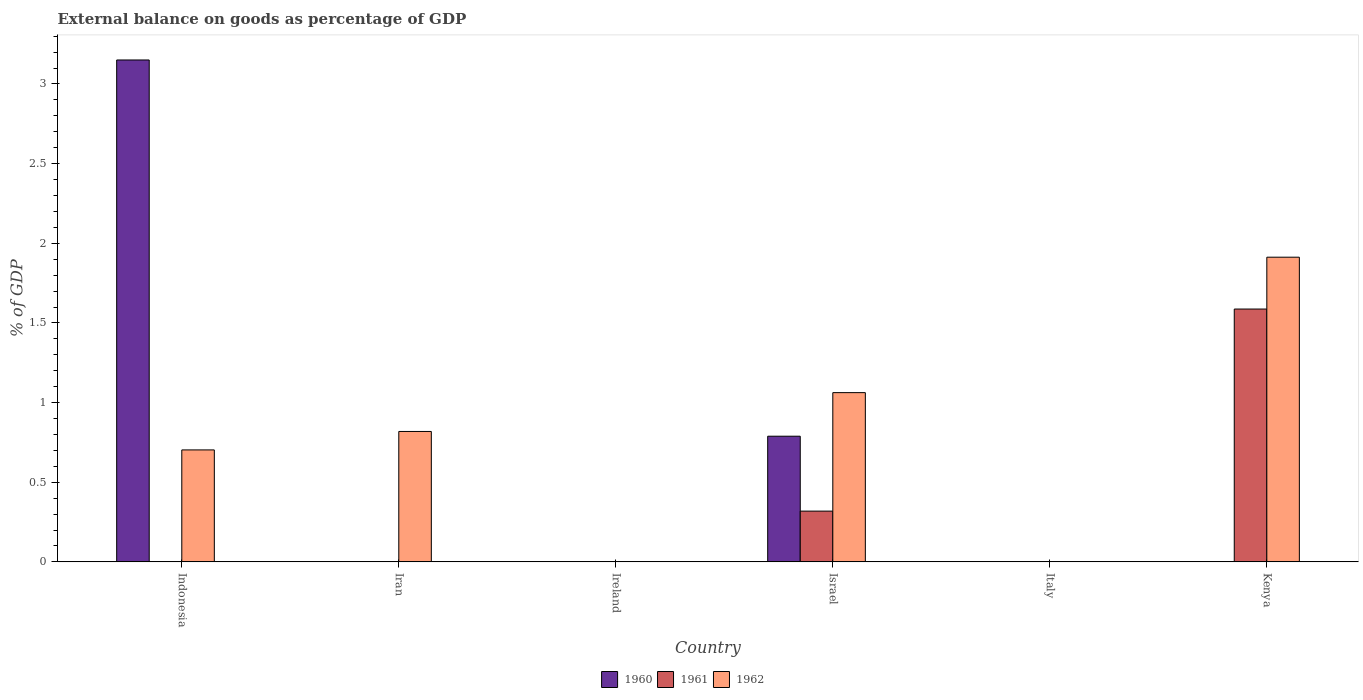How many different coloured bars are there?
Provide a short and direct response. 3. Are the number of bars per tick equal to the number of legend labels?
Provide a succinct answer. No. How many bars are there on the 3rd tick from the left?
Your answer should be very brief. 0. What is the label of the 3rd group of bars from the left?
Provide a succinct answer. Ireland. In how many cases, is the number of bars for a given country not equal to the number of legend labels?
Make the answer very short. 5. What is the external balance on goods as percentage of GDP in 1962 in Israel?
Provide a short and direct response. 1.06. Across all countries, what is the maximum external balance on goods as percentage of GDP in 1960?
Offer a terse response. 3.15. Across all countries, what is the minimum external balance on goods as percentage of GDP in 1961?
Your answer should be very brief. 0. In which country was the external balance on goods as percentage of GDP in 1961 maximum?
Offer a very short reply. Kenya. What is the total external balance on goods as percentage of GDP in 1961 in the graph?
Offer a terse response. 1.91. What is the difference between the external balance on goods as percentage of GDP in 1962 in Iran and that in Kenya?
Offer a terse response. -1.09. What is the difference between the external balance on goods as percentage of GDP in 1962 in Kenya and the external balance on goods as percentage of GDP in 1961 in Israel?
Provide a succinct answer. 1.59. What is the average external balance on goods as percentage of GDP in 1960 per country?
Give a very brief answer. 0.66. What is the difference between the external balance on goods as percentage of GDP of/in 1960 and external balance on goods as percentage of GDP of/in 1961 in Israel?
Offer a very short reply. 0.47. What is the ratio of the external balance on goods as percentage of GDP in 1962 in Iran to that in Israel?
Your answer should be very brief. 0.77. Is the external balance on goods as percentage of GDP in 1962 in Indonesia less than that in Iran?
Give a very brief answer. Yes. What is the difference between the highest and the second highest external balance on goods as percentage of GDP in 1962?
Provide a short and direct response. -1.09. What is the difference between the highest and the lowest external balance on goods as percentage of GDP in 1960?
Offer a very short reply. 3.15. Is the sum of the external balance on goods as percentage of GDP in 1962 in Israel and Kenya greater than the maximum external balance on goods as percentage of GDP in 1961 across all countries?
Provide a short and direct response. Yes. Is it the case that in every country, the sum of the external balance on goods as percentage of GDP in 1960 and external balance on goods as percentage of GDP in 1962 is greater than the external balance on goods as percentage of GDP in 1961?
Keep it short and to the point. No. How many bars are there?
Provide a succinct answer. 8. Are all the bars in the graph horizontal?
Give a very brief answer. No. How many countries are there in the graph?
Your response must be concise. 6. How many legend labels are there?
Offer a terse response. 3. What is the title of the graph?
Your response must be concise. External balance on goods as percentage of GDP. What is the label or title of the X-axis?
Offer a very short reply. Country. What is the label or title of the Y-axis?
Provide a short and direct response. % of GDP. What is the % of GDP of 1960 in Indonesia?
Provide a succinct answer. 3.15. What is the % of GDP in 1961 in Indonesia?
Your response must be concise. 0. What is the % of GDP of 1962 in Indonesia?
Ensure brevity in your answer.  0.7. What is the % of GDP of 1960 in Iran?
Offer a very short reply. 0. What is the % of GDP of 1961 in Iran?
Provide a succinct answer. 0. What is the % of GDP in 1962 in Iran?
Your answer should be very brief. 0.82. What is the % of GDP of 1961 in Ireland?
Your response must be concise. 0. What is the % of GDP in 1962 in Ireland?
Ensure brevity in your answer.  0. What is the % of GDP in 1960 in Israel?
Keep it short and to the point. 0.79. What is the % of GDP of 1961 in Israel?
Your answer should be compact. 0.32. What is the % of GDP of 1962 in Israel?
Keep it short and to the point. 1.06. What is the % of GDP of 1962 in Italy?
Provide a short and direct response. 0. What is the % of GDP of 1960 in Kenya?
Give a very brief answer. 0. What is the % of GDP of 1961 in Kenya?
Make the answer very short. 1.59. What is the % of GDP in 1962 in Kenya?
Offer a very short reply. 1.91. Across all countries, what is the maximum % of GDP in 1960?
Ensure brevity in your answer.  3.15. Across all countries, what is the maximum % of GDP of 1961?
Your answer should be compact. 1.59. Across all countries, what is the maximum % of GDP in 1962?
Your answer should be compact. 1.91. Across all countries, what is the minimum % of GDP of 1960?
Keep it short and to the point. 0. Across all countries, what is the minimum % of GDP of 1961?
Your answer should be compact. 0. Across all countries, what is the minimum % of GDP of 1962?
Your response must be concise. 0. What is the total % of GDP of 1960 in the graph?
Your response must be concise. 3.94. What is the total % of GDP of 1961 in the graph?
Offer a very short reply. 1.91. What is the total % of GDP in 1962 in the graph?
Keep it short and to the point. 4.5. What is the difference between the % of GDP in 1962 in Indonesia and that in Iran?
Make the answer very short. -0.12. What is the difference between the % of GDP in 1960 in Indonesia and that in Israel?
Provide a succinct answer. 2.36. What is the difference between the % of GDP of 1962 in Indonesia and that in Israel?
Keep it short and to the point. -0.36. What is the difference between the % of GDP in 1962 in Indonesia and that in Kenya?
Your answer should be very brief. -1.21. What is the difference between the % of GDP in 1962 in Iran and that in Israel?
Offer a very short reply. -0.24. What is the difference between the % of GDP in 1962 in Iran and that in Kenya?
Provide a short and direct response. -1.09. What is the difference between the % of GDP of 1961 in Israel and that in Kenya?
Keep it short and to the point. -1.27. What is the difference between the % of GDP in 1962 in Israel and that in Kenya?
Keep it short and to the point. -0.85. What is the difference between the % of GDP in 1960 in Indonesia and the % of GDP in 1962 in Iran?
Your response must be concise. 2.33. What is the difference between the % of GDP of 1960 in Indonesia and the % of GDP of 1961 in Israel?
Provide a succinct answer. 2.83. What is the difference between the % of GDP of 1960 in Indonesia and the % of GDP of 1962 in Israel?
Your answer should be very brief. 2.09. What is the difference between the % of GDP of 1960 in Indonesia and the % of GDP of 1961 in Kenya?
Your response must be concise. 1.56. What is the difference between the % of GDP in 1960 in Indonesia and the % of GDP in 1962 in Kenya?
Make the answer very short. 1.24. What is the difference between the % of GDP of 1960 in Israel and the % of GDP of 1961 in Kenya?
Provide a short and direct response. -0.8. What is the difference between the % of GDP in 1960 in Israel and the % of GDP in 1962 in Kenya?
Ensure brevity in your answer.  -1.12. What is the difference between the % of GDP of 1961 in Israel and the % of GDP of 1962 in Kenya?
Your answer should be compact. -1.59. What is the average % of GDP in 1960 per country?
Ensure brevity in your answer.  0.66. What is the average % of GDP of 1961 per country?
Ensure brevity in your answer.  0.32. What is the average % of GDP of 1962 per country?
Give a very brief answer. 0.75. What is the difference between the % of GDP in 1960 and % of GDP in 1962 in Indonesia?
Your answer should be compact. 2.45. What is the difference between the % of GDP of 1960 and % of GDP of 1961 in Israel?
Your response must be concise. 0.47. What is the difference between the % of GDP of 1960 and % of GDP of 1962 in Israel?
Your answer should be very brief. -0.27. What is the difference between the % of GDP in 1961 and % of GDP in 1962 in Israel?
Offer a very short reply. -0.74. What is the difference between the % of GDP in 1961 and % of GDP in 1962 in Kenya?
Offer a very short reply. -0.33. What is the ratio of the % of GDP of 1962 in Indonesia to that in Iran?
Offer a terse response. 0.86. What is the ratio of the % of GDP in 1960 in Indonesia to that in Israel?
Offer a terse response. 3.99. What is the ratio of the % of GDP in 1962 in Indonesia to that in Israel?
Give a very brief answer. 0.66. What is the ratio of the % of GDP of 1962 in Indonesia to that in Kenya?
Provide a succinct answer. 0.37. What is the ratio of the % of GDP in 1962 in Iran to that in Israel?
Make the answer very short. 0.77. What is the ratio of the % of GDP of 1962 in Iran to that in Kenya?
Make the answer very short. 0.43. What is the ratio of the % of GDP in 1961 in Israel to that in Kenya?
Your answer should be very brief. 0.2. What is the ratio of the % of GDP of 1962 in Israel to that in Kenya?
Provide a short and direct response. 0.56. What is the difference between the highest and the second highest % of GDP in 1962?
Give a very brief answer. 0.85. What is the difference between the highest and the lowest % of GDP in 1960?
Make the answer very short. 3.15. What is the difference between the highest and the lowest % of GDP in 1961?
Offer a very short reply. 1.59. What is the difference between the highest and the lowest % of GDP of 1962?
Offer a very short reply. 1.91. 